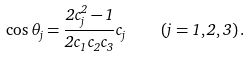Convert formula to latex. <formula><loc_0><loc_0><loc_500><loc_500>\cos \theta _ { j } = \frac { 2 c _ { j } ^ { 2 } - 1 } { 2 c _ { 1 } c _ { 2 } c _ { 3 } } c _ { j } \quad ( j = 1 , 2 , 3 ) \, .</formula> 